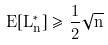Convert formula to latex. <formula><loc_0><loc_0><loc_500><loc_500>E [ L _ { n } ^ { * } ] \geq \frac { 1 } { 2 } \sqrt { n }</formula> 